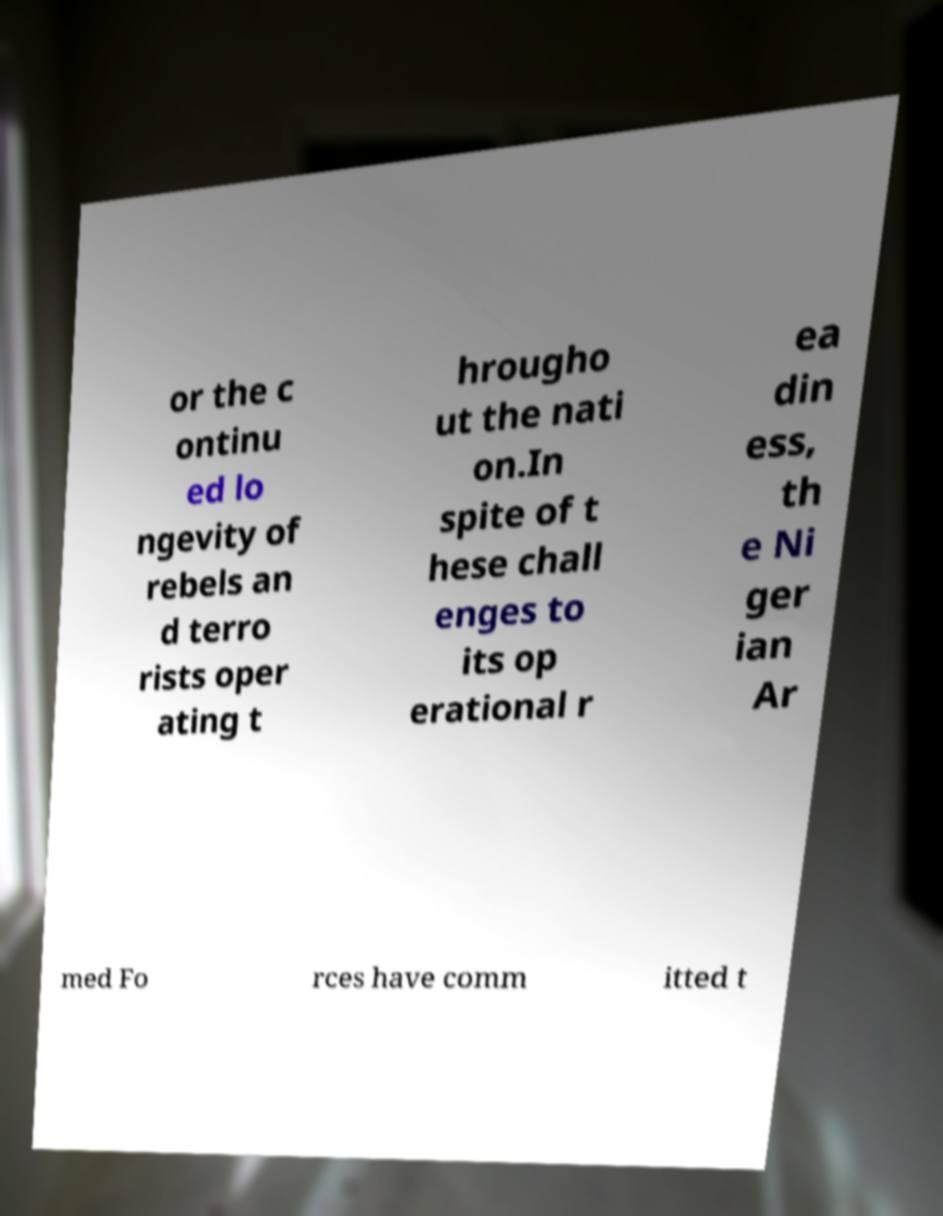Please identify and transcribe the text found in this image. or the c ontinu ed lo ngevity of rebels an d terro rists oper ating t hrougho ut the nati on.In spite of t hese chall enges to its op erational r ea din ess, th e Ni ger ian Ar med Fo rces have comm itted t 